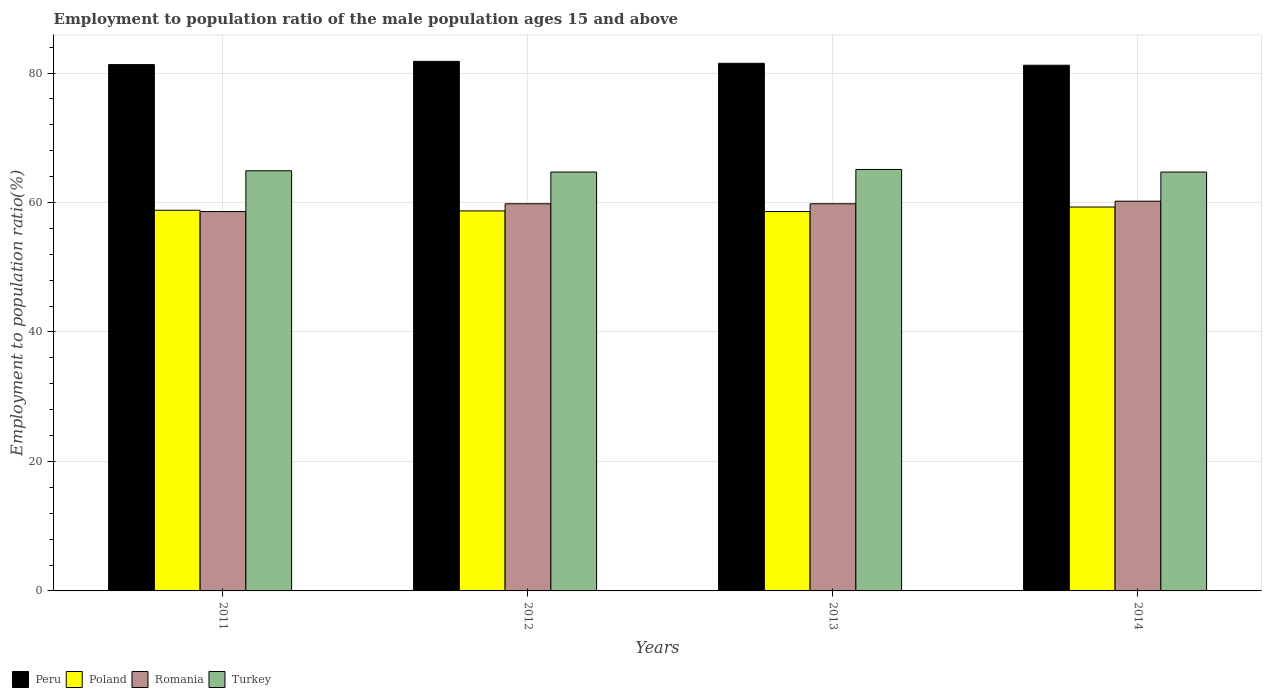How many different coloured bars are there?
Offer a very short reply. 4. Are the number of bars on each tick of the X-axis equal?
Your answer should be very brief. Yes. How many bars are there on the 3rd tick from the left?
Offer a terse response. 4. What is the label of the 1st group of bars from the left?
Keep it short and to the point. 2011. What is the employment to population ratio in Romania in 2011?
Give a very brief answer. 58.6. Across all years, what is the maximum employment to population ratio in Peru?
Give a very brief answer. 81.8. Across all years, what is the minimum employment to population ratio in Turkey?
Give a very brief answer. 64.7. In which year was the employment to population ratio in Poland maximum?
Keep it short and to the point. 2014. In which year was the employment to population ratio in Poland minimum?
Offer a very short reply. 2013. What is the total employment to population ratio in Turkey in the graph?
Provide a short and direct response. 259.4. What is the difference between the employment to population ratio in Turkey in 2011 and that in 2014?
Your answer should be compact. 0.2. What is the difference between the employment to population ratio in Peru in 2011 and the employment to population ratio in Romania in 2014?
Provide a succinct answer. 21.1. What is the average employment to population ratio in Poland per year?
Give a very brief answer. 58.85. In the year 2012, what is the difference between the employment to population ratio in Peru and employment to population ratio in Poland?
Offer a terse response. 23.1. In how many years, is the employment to population ratio in Romania greater than 60 %?
Ensure brevity in your answer.  1. What is the ratio of the employment to population ratio in Poland in 2011 to that in 2013?
Offer a terse response. 1. What is the difference between the highest and the lowest employment to population ratio in Peru?
Provide a short and direct response. 0.6. Is the sum of the employment to population ratio in Turkey in 2013 and 2014 greater than the maximum employment to population ratio in Romania across all years?
Provide a succinct answer. Yes. Is it the case that in every year, the sum of the employment to population ratio in Peru and employment to population ratio in Turkey is greater than the sum of employment to population ratio in Poland and employment to population ratio in Romania?
Provide a succinct answer. Yes. How many years are there in the graph?
Provide a short and direct response. 4. Are the values on the major ticks of Y-axis written in scientific E-notation?
Provide a succinct answer. No. How many legend labels are there?
Offer a terse response. 4. How are the legend labels stacked?
Your answer should be very brief. Horizontal. What is the title of the graph?
Make the answer very short. Employment to population ratio of the male population ages 15 and above. What is the label or title of the X-axis?
Your response must be concise. Years. What is the label or title of the Y-axis?
Your answer should be compact. Employment to population ratio(%). What is the Employment to population ratio(%) in Peru in 2011?
Provide a succinct answer. 81.3. What is the Employment to population ratio(%) in Poland in 2011?
Provide a short and direct response. 58.8. What is the Employment to population ratio(%) in Romania in 2011?
Provide a succinct answer. 58.6. What is the Employment to population ratio(%) of Turkey in 2011?
Keep it short and to the point. 64.9. What is the Employment to population ratio(%) of Peru in 2012?
Your answer should be very brief. 81.8. What is the Employment to population ratio(%) in Poland in 2012?
Your answer should be very brief. 58.7. What is the Employment to population ratio(%) in Romania in 2012?
Offer a very short reply. 59.8. What is the Employment to population ratio(%) in Turkey in 2012?
Ensure brevity in your answer.  64.7. What is the Employment to population ratio(%) of Peru in 2013?
Keep it short and to the point. 81.5. What is the Employment to population ratio(%) in Poland in 2013?
Your answer should be very brief. 58.6. What is the Employment to population ratio(%) of Romania in 2013?
Offer a terse response. 59.8. What is the Employment to population ratio(%) in Turkey in 2013?
Your response must be concise. 65.1. What is the Employment to population ratio(%) of Peru in 2014?
Keep it short and to the point. 81.2. What is the Employment to population ratio(%) in Poland in 2014?
Offer a terse response. 59.3. What is the Employment to population ratio(%) of Romania in 2014?
Your answer should be compact. 60.2. What is the Employment to population ratio(%) in Turkey in 2014?
Keep it short and to the point. 64.7. Across all years, what is the maximum Employment to population ratio(%) in Peru?
Provide a succinct answer. 81.8. Across all years, what is the maximum Employment to population ratio(%) of Poland?
Keep it short and to the point. 59.3. Across all years, what is the maximum Employment to population ratio(%) in Romania?
Provide a succinct answer. 60.2. Across all years, what is the maximum Employment to population ratio(%) in Turkey?
Provide a short and direct response. 65.1. Across all years, what is the minimum Employment to population ratio(%) in Peru?
Give a very brief answer. 81.2. Across all years, what is the minimum Employment to population ratio(%) of Poland?
Offer a very short reply. 58.6. Across all years, what is the minimum Employment to population ratio(%) in Romania?
Ensure brevity in your answer.  58.6. Across all years, what is the minimum Employment to population ratio(%) in Turkey?
Provide a succinct answer. 64.7. What is the total Employment to population ratio(%) in Peru in the graph?
Provide a succinct answer. 325.8. What is the total Employment to population ratio(%) in Poland in the graph?
Make the answer very short. 235.4. What is the total Employment to population ratio(%) in Romania in the graph?
Give a very brief answer. 238.4. What is the total Employment to population ratio(%) in Turkey in the graph?
Ensure brevity in your answer.  259.4. What is the difference between the Employment to population ratio(%) of Peru in 2011 and that in 2012?
Keep it short and to the point. -0.5. What is the difference between the Employment to population ratio(%) of Poland in 2011 and that in 2012?
Keep it short and to the point. 0.1. What is the difference between the Employment to population ratio(%) of Turkey in 2011 and that in 2012?
Your answer should be very brief. 0.2. What is the difference between the Employment to population ratio(%) of Romania in 2011 and that in 2013?
Make the answer very short. -1.2. What is the difference between the Employment to population ratio(%) of Romania in 2011 and that in 2014?
Your answer should be very brief. -1.6. What is the difference between the Employment to population ratio(%) in Turkey in 2011 and that in 2014?
Offer a terse response. 0.2. What is the difference between the Employment to population ratio(%) in Peru in 2012 and that in 2013?
Offer a terse response. 0.3. What is the difference between the Employment to population ratio(%) in Poland in 2012 and that in 2013?
Offer a terse response. 0.1. What is the difference between the Employment to population ratio(%) of Peru in 2012 and that in 2014?
Your answer should be very brief. 0.6. What is the difference between the Employment to population ratio(%) of Turkey in 2012 and that in 2014?
Your answer should be compact. 0. What is the difference between the Employment to population ratio(%) of Poland in 2013 and that in 2014?
Offer a terse response. -0.7. What is the difference between the Employment to population ratio(%) of Romania in 2013 and that in 2014?
Your response must be concise. -0.4. What is the difference between the Employment to population ratio(%) of Turkey in 2013 and that in 2014?
Ensure brevity in your answer.  0.4. What is the difference between the Employment to population ratio(%) in Peru in 2011 and the Employment to population ratio(%) in Poland in 2012?
Offer a very short reply. 22.6. What is the difference between the Employment to population ratio(%) of Peru in 2011 and the Employment to population ratio(%) of Turkey in 2012?
Provide a succinct answer. 16.6. What is the difference between the Employment to population ratio(%) of Poland in 2011 and the Employment to population ratio(%) of Romania in 2012?
Make the answer very short. -1. What is the difference between the Employment to population ratio(%) of Romania in 2011 and the Employment to population ratio(%) of Turkey in 2012?
Ensure brevity in your answer.  -6.1. What is the difference between the Employment to population ratio(%) of Peru in 2011 and the Employment to population ratio(%) of Poland in 2013?
Offer a terse response. 22.7. What is the difference between the Employment to population ratio(%) in Peru in 2011 and the Employment to population ratio(%) in Romania in 2013?
Your answer should be very brief. 21.5. What is the difference between the Employment to population ratio(%) of Poland in 2011 and the Employment to population ratio(%) of Romania in 2013?
Your answer should be compact. -1. What is the difference between the Employment to population ratio(%) of Poland in 2011 and the Employment to population ratio(%) of Turkey in 2013?
Make the answer very short. -6.3. What is the difference between the Employment to population ratio(%) in Peru in 2011 and the Employment to population ratio(%) in Poland in 2014?
Your answer should be compact. 22. What is the difference between the Employment to population ratio(%) of Peru in 2011 and the Employment to population ratio(%) of Romania in 2014?
Give a very brief answer. 21.1. What is the difference between the Employment to population ratio(%) of Poland in 2011 and the Employment to population ratio(%) of Turkey in 2014?
Your answer should be very brief. -5.9. What is the difference between the Employment to population ratio(%) in Peru in 2012 and the Employment to population ratio(%) in Poland in 2013?
Make the answer very short. 23.2. What is the difference between the Employment to population ratio(%) of Peru in 2012 and the Employment to population ratio(%) of Romania in 2013?
Ensure brevity in your answer.  22. What is the difference between the Employment to population ratio(%) in Peru in 2012 and the Employment to population ratio(%) in Turkey in 2013?
Make the answer very short. 16.7. What is the difference between the Employment to population ratio(%) in Peru in 2012 and the Employment to population ratio(%) in Poland in 2014?
Make the answer very short. 22.5. What is the difference between the Employment to population ratio(%) in Peru in 2012 and the Employment to population ratio(%) in Romania in 2014?
Provide a succinct answer. 21.6. What is the difference between the Employment to population ratio(%) in Peru in 2012 and the Employment to population ratio(%) in Turkey in 2014?
Your answer should be compact. 17.1. What is the difference between the Employment to population ratio(%) in Poland in 2012 and the Employment to population ratio(%) in Romania in 2014?
Provide a succinct answer. -1.5. What is the difference between the Employment to population ratio(%) of Poland in 2012 and the Employment to population ratio(%) of Turkey in 2014?
Make the answer very short. -6. What is the difference between the Employment to population ratio(%) in Peru in 2013 and the Employment to population ratio(%) in Poland in 2014?
Ensure brevity in your answer.  22.2. What is the difference between the Employment to population ratio(%) of Peru in 2013 and the Employment to population ratio(%) of Romania in 2014?
Ensure brevity in your answer.  21.3. What is the difference between the Employment to population ratio(%) in Peru in 2013 and the Employment to population ratio(%) in Turkey in 2014?
Your response must be concise. 16.8. What is the difference between the Employment to population ratio(%) in Poland in 2013 and the Employment to population ratio(%) in Romania in 2014?
Give a very brief answer. -1.6. What is the average Employment to population ratio(%) in Peru per year?
Ensure brevity in your answer.  81.45. What is the average Employment to population ratio(%) in Poland per year?
Your answer should be very brief. 58.85. What is the average Employment to population ratio(%) of Romania per year?
Provide a short and direct response. 59.6. What is the average Employment to population ratio(%) of Turkey per year?
Offer a terse response. 64.85. In the year 2011, what is the difference between the Employment to population ratio(%) in Peru and Employment to population ratio(%) in Romania?
Provide a short and direct response. 22.7. In the year 2011, what is the difference between the Employment to population ratio(%) in Romania and Employment to population ratio(%) in Turkey?
Provide a succinct answer. -6.3. In the year 2012, what is the difference between the Employment to population ratio(%) of Peru and Employment to population ratio(%) of Poland?
Your answer should be very brief. 23.1. In the year 2012, what is the difference between the Employment to population ratio(%) of Peru and Employment to population ratio(%) of Turkey?
Your answer should be compact. 17.1. In the year 2012, what is the difference between the Employment to population ratio(%) in Poland and Employment to population ratio(%) in Romania?
Your answer should be compact. -1.1. In the year 2012, what is the difference between the Employment to population ratio(%) in Poland and Employment to population ratio(%) in Turkey?
Keep it short and to the point. -6. In the year 2013, what is the difference between the Employment to population ratio(%) in Peru and Employment to population ratio(%) in Poland?
Provide a short and direct response. 22.9. In the year 2013, what is the difference between the Employment to population ratio(%) of Peru and Employment to population ratio(%) of Romania?
Your answer should be very brief. 21.7. In the year 2013, what is the difference between the Employment to population ratio(%) of Peru and Employment to population ratio(%) of Turkey?
Make the answer very short. 16.4. In the year 2014, what is the difference between the Employment to population ratio(%) in Peru and Employment to population ratio(%) in Poland?
Your response must be concise. 21.9. In the year 2014, what is the difference between the Employment to population ratio(%) of Peru and Employment to population ratio(%) of Romania?
Make the answer very short. 21. In the year 2014, what is the difference between the Employment to population ratio(%) in Poland and Employment to population ratio(%) in Romania?
Offer a very short reply. -0.9. In the year 2014, what is the difference between the Employment to population ratio(%) of Romania and Employment to population ratio(%) of Turkey?
Make the answer very short. -4.5. What is the ratio of the Employment to population ratio(%) of Peru in 2011 to that in 2012?
Your response must be concise. 0.99. What is the ratio of the Employment to population ratio(%) of Poland in 2011 to that in 2012?
Give a very brief answer. 1. What is the ratio of the Employment to population ratio(%) of Romania in 2011 to that in 2012?
Your answer should be compact. 0.98. What is the ratio of the Employment to population ratio(%) of Romania in 2011 to that in 2013?
Provide a succinct answer. 0.98. What is the ratio of the Employment to population ratio(%) in Turkey in 2011 to that in 2013?
Ensure brevity in your answer.  1. What is the ratio of the Employment to population ratio(%) of Peru in 2011 to that in 2014?
Your answer should be very brief. 1. What is the ratio of the Employment to population ratio(%) in Poland in 2011 to that in 2014?
Offer a terse response. 0.99. What is the ratio of the Employment to population ratio(%) of Romania in 2011 to that in 2014?
Your answer should be very brief. 0.97. What is the ratio of the Employment to population ratio(%) of Turkey in 2011 to that in 2014?
Provide a short and direct response. 1. What is the ratio of the Employment to population ratio(%) in Peru in 2012 to that in 2013?
Your answer should be compact. 1. What is the ratio of the Employment to population ratio(%) in Romania in 2012 to that in 2013?
Ensure brevity in your answer.  1. What is the ratio of the Employment to population ratio(%) of Peru in 2012 to that in 2014?
Ensure brevity in your answer.  1.01. What is the ratio of the Employment to population ratio(%) of Turkey in 2012 to that in 2014?
Keep it short and to the point. 1. What is the ratio of the Employment to population ratio(%) of Poland in 2013 to that in 2014?
Your answer should be compact. 0.99. What is the difference between the highest and the second highest Employment to population ratio(%) of Turkey?
Keep it short and to the point. 0.2. What is the difference between the highest and the lowest Employment to population ratio(%) of Peru?
Give a very brief answer. 0.6. What is the difference between the highest and the lowest Employment to population ratio(%) in Turkey?
Provide a succinct answer. 0.4. 